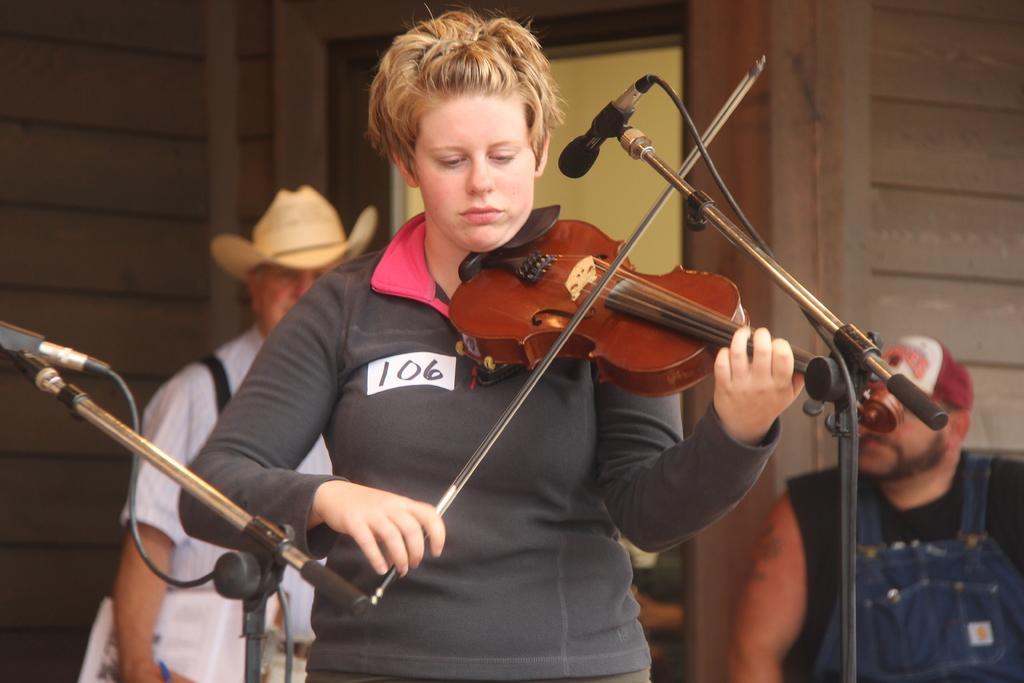Can you describe this image briefly? In this image we can see a person is playing guitar. There are mikes and two persons. In the background we can see wall and an object. 